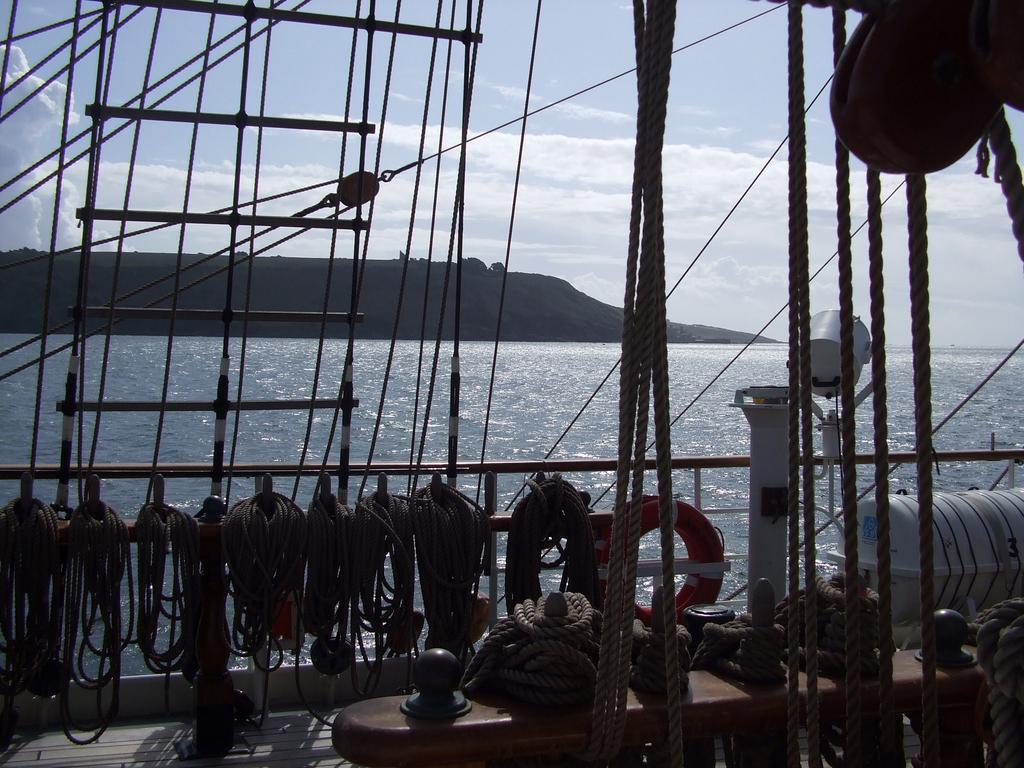Can you describe this image briefly? In this image, I can see the ropes, lifeboat barrel, lifebuoy and few other objects. There is water and a hill. In the background, I can see the sky. 